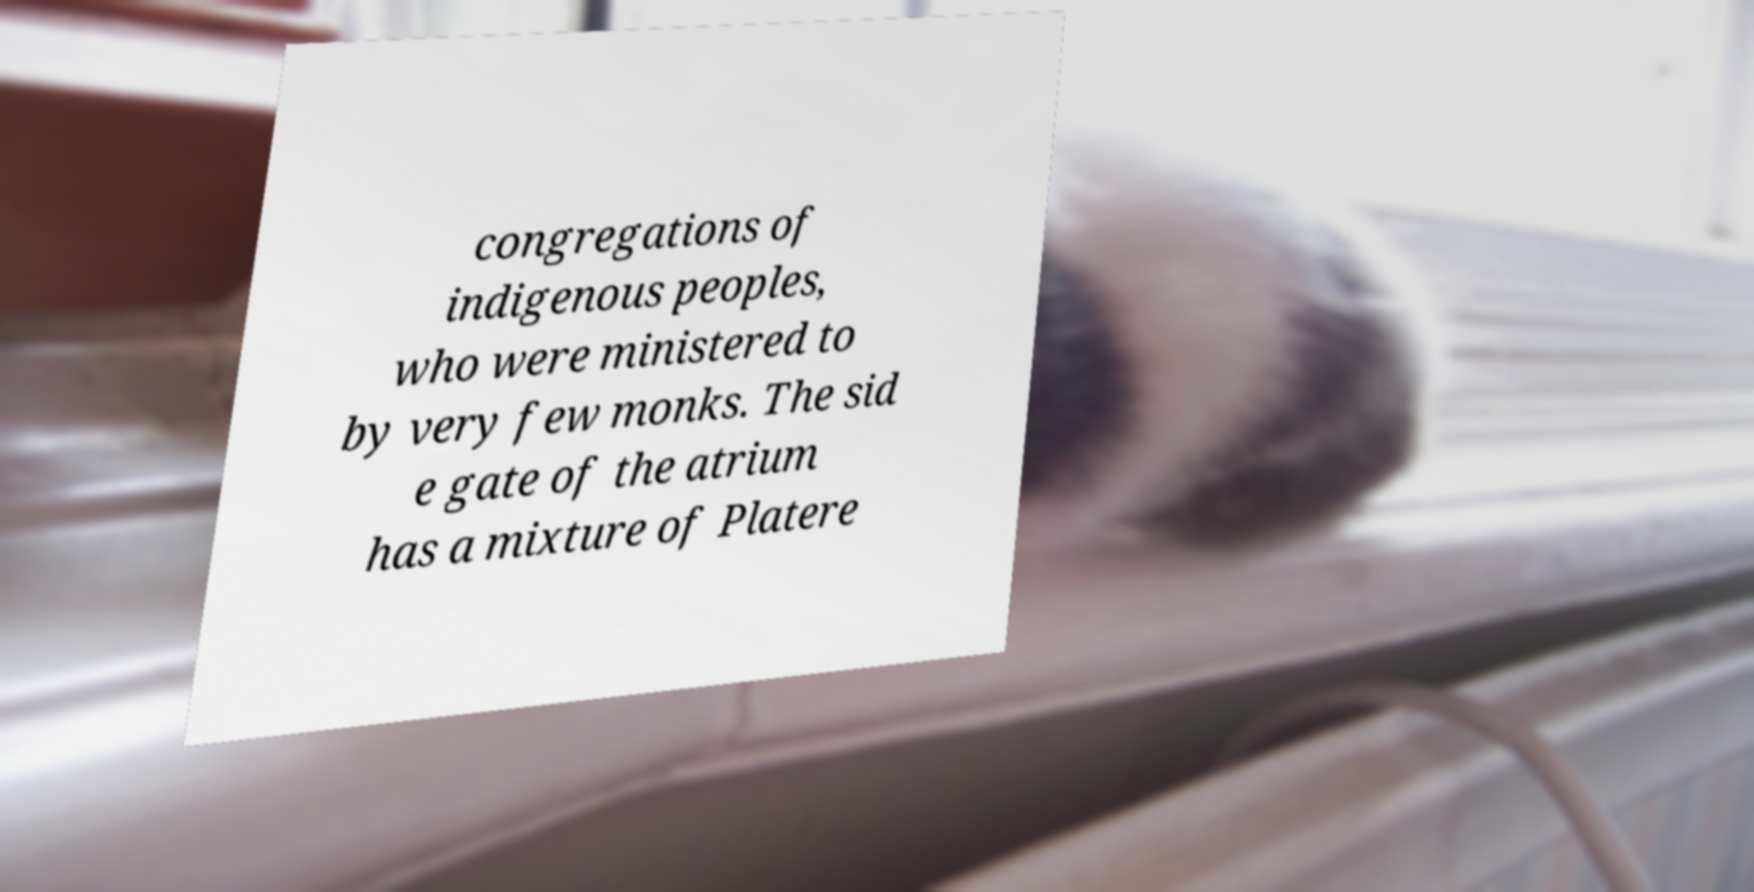What messages or text are displayed in this image? I need them in a readable, typed format. congregations of indigenous peoples, who were ministered to by very few monks. The sid e gate of the atrium has a mixture of Platere 